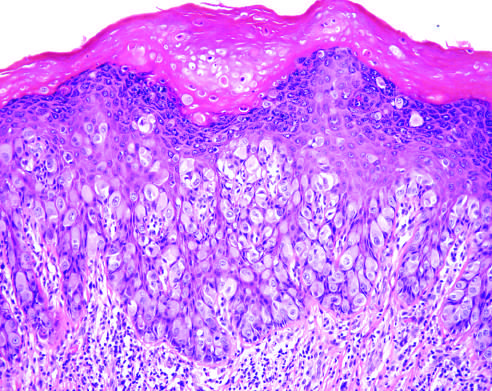re large tumor cells with pale-pink cytoplasm seen infiltrating the epidermis?
Answer the question using a single word or phrase. Yes 